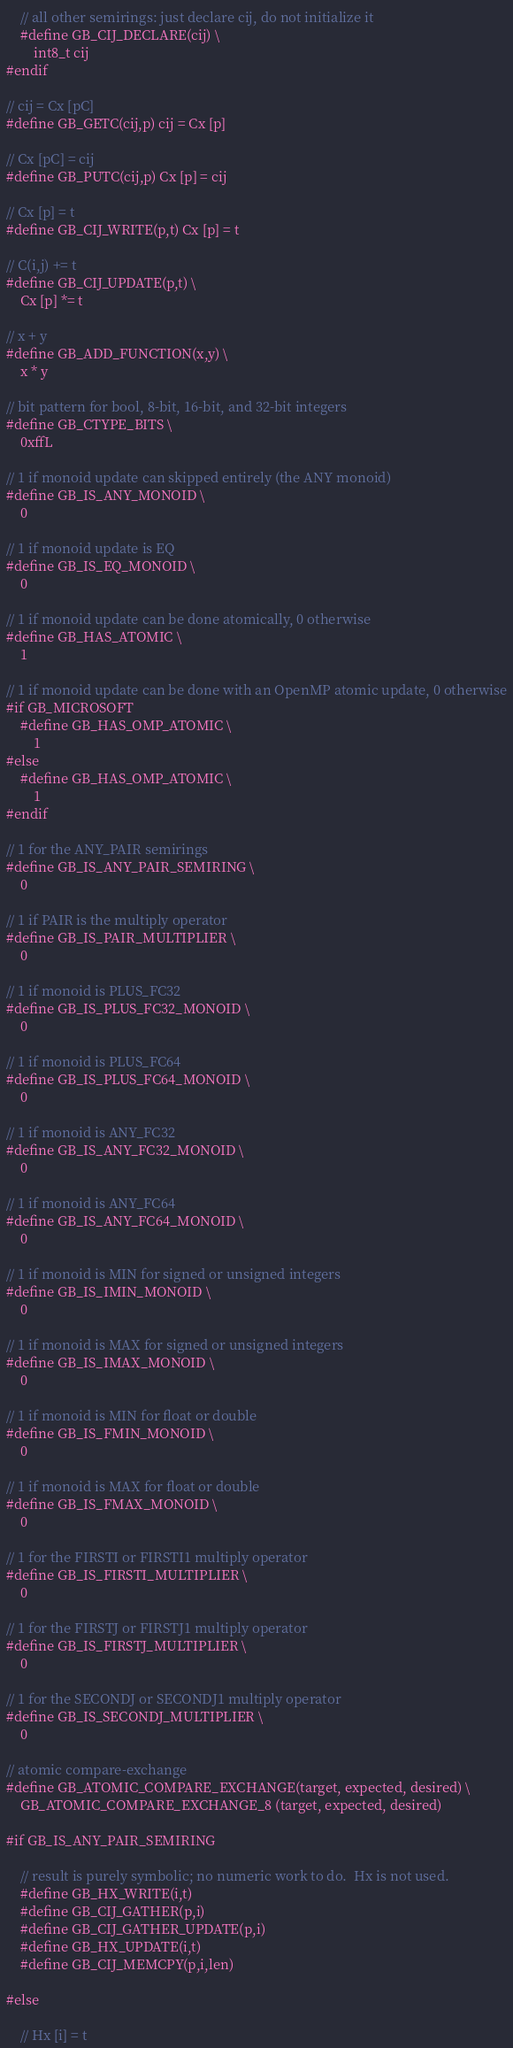<code> <loc_0><loc_0><loc_500><loc_500><_C_>    // all other semirings: just declare cij, do not initialize it
    #define GB_CIJ_DECLARE(cij) \
        int8_t cij
#endif

// cij = Cx [pC]
#define GB_GETC(cij,p) cij = Cx [p]

// Cx [pC] = cij
#define GB_PUTC(cij,p) Cx [p] = cij

// Cx [p] = t
#define GB_CIJ_WRITE(p,t) Cx [p] = t

// C(i,j) += t
#define GB_CIJ_UPDATE(p,t) \
    Cx [p] *= t

// x + y
#define GB_ADD_FUNCTION(x,y) \
    x * y

// bit pattern for bool, 8-bit, 16-bit, and 32-bit integers
#define GB_CTYPE_BITS \
    0xffL

// 1 if monoid update can skipped entirely (the ANY monoid)
#define GB_IS_ANY_MONOID \
    0

// 1 if monoid update is EQ
#define GB_IS_EQ_MONOID \
    0

// 1 if monoid update can be done atomically, 0 otherwise
#define GB_HAS_ATOMIC \
    1

// 1 if monoid update can be done with an OpenMP atomic update, 0 otherwise
#if GB_MICROSOFT
    #define GB_HAS_OMP_ATOMIC \
        1
#else
    #define GB_HAS_OMP_ATOMIC \
        1
#endif

// 1 for the ANY_PAIR semirings
#define GB_IS_ANY_PAIR_SEMIRING \
    0

// 1 if PAIR is the multiply operator 
#define GB_IS_PAIR_MULTIPLIER \
    0

// 1 if monoid is PLUS_FC32
#define GB_IS_PLUS_FC32_MONOID \
    0

// 1 if monoid is PLUS_FC64
#define GB_IS_PLUS_FC64_MONOID \
    0

// 1 if monoid is ANY_FC32
#define GB_IS_ANY_FC32_MONOID \
    0

// 1 if monoid is ANY_FC64
#define GB_IS_ANY_FC64_MONOID \
    0

// 1 if monoid is MIN for signed or unsigned integers
#define GB_IS_IMIN_MONOID \
    0

// 1 if monoid is MAX for signed or unsigned integers
#define GB_IS_IMAX_MONOID \
    0

// 1 if monoid is MIN for float or double
#define GB_IS_FMIN_MONOID \
    0

// 1 if monoid is MAX for float or double
#define GB_IS_FMAX_MONOID \
    0

// 1 for the FIRSTI or FIRSTI1 multiply operator
#define GB_IS_FIRSTI_MULTIPLIER \
    0

// 1 for the FIRSTJ or FIRSTJ1 multiply operator
#define GB_IS_FIRSTJ_MULTIPLIER \
    0

// 1 for the SECONDJ or SECONDJ1 multiply operator
#define GB_IS_SECONDJ_MULTIPLIER \
    0

// atomic compare-exchange
#define GB_ATOMIC_COMPARE_EXCHANGE(target, expected, desired) \
    GB_ATOMIC_COMPARE_EXCHANGE_8 (target, expected, desired)

#if GB_IS_ANY_PAIR_SEMIRING

    // result is purely symbolic; no numeric work to do.  Hx is not used.
    #define GB_HX_WRITE(i,t)
    #define GB_CIJ_GATHER(p,i)
    #define GB_CIJ_GATHER_UPDATE(p,i)
    #define GB_HX_UPDATE(i,t)
    #define GB_CIJ_MEMCPY(p,i,len)

#else

    // Hx [i] = t</code> 